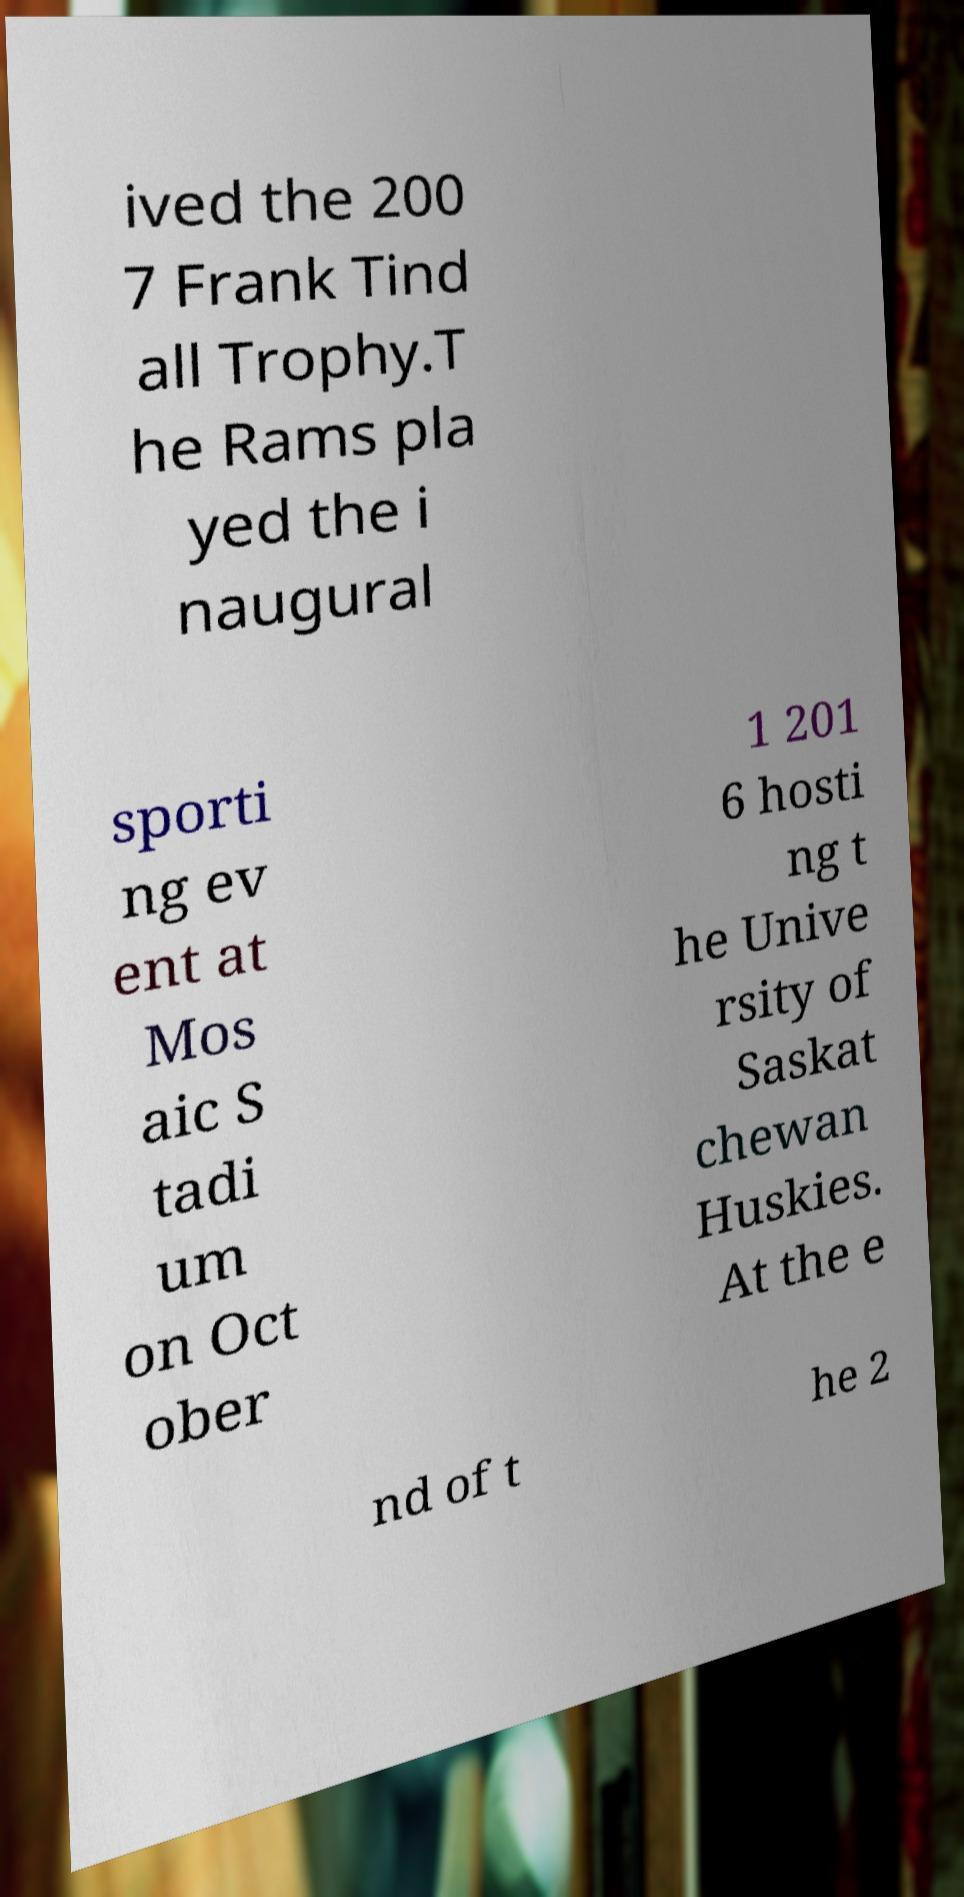Please identify and transcribe the text found in this image. ived the 200 7 Frank Tind all Trophy.T he Rams pla yed the i naugural sporti ng ev ent at Mos aic S tadi um on Oct ober 1 201 6 hosti ng t he Unive rsity of Saskat chewan Huskies. At the e nd of t he 2 